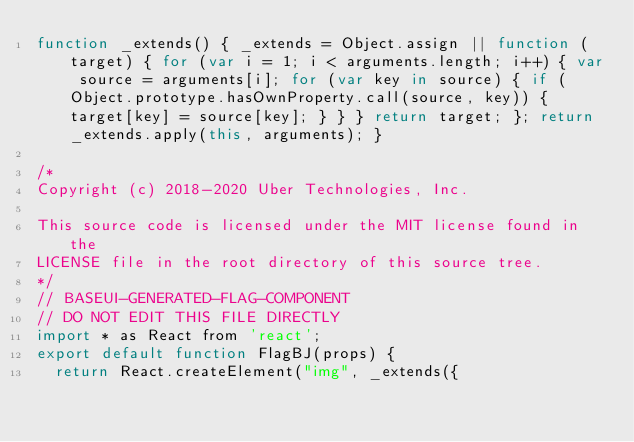Convert code to text. <code><loc_0><loc_0><loc_500><loc_500><_JavaScript_>function _extends() { _extends = Object.assign || function (target) { for (var i = 1; i < arguments.length; i++) { var source = arguments[i]; for (var key in source) { if (Object.prototype.hasOwnProperty.call(source, key)) { target[key] = source[key]; } } } return target; }; return _extends.apply(this, arguments); }

/*
Copyright (c) 2018-2020 Uber Technologies, Inc.

This source code is licensed under the MIT license found in the
LICENSE file in the root directory of this source tree.
*/
// BASEUI-GENERATED-FLAG-COMPONENT
// DO NOT EDIT THIS FILE DIRECTLY
import * as React from 'react';
export default function FlagBJ(props) {
  return React.createElement("img", _extends({</code> 